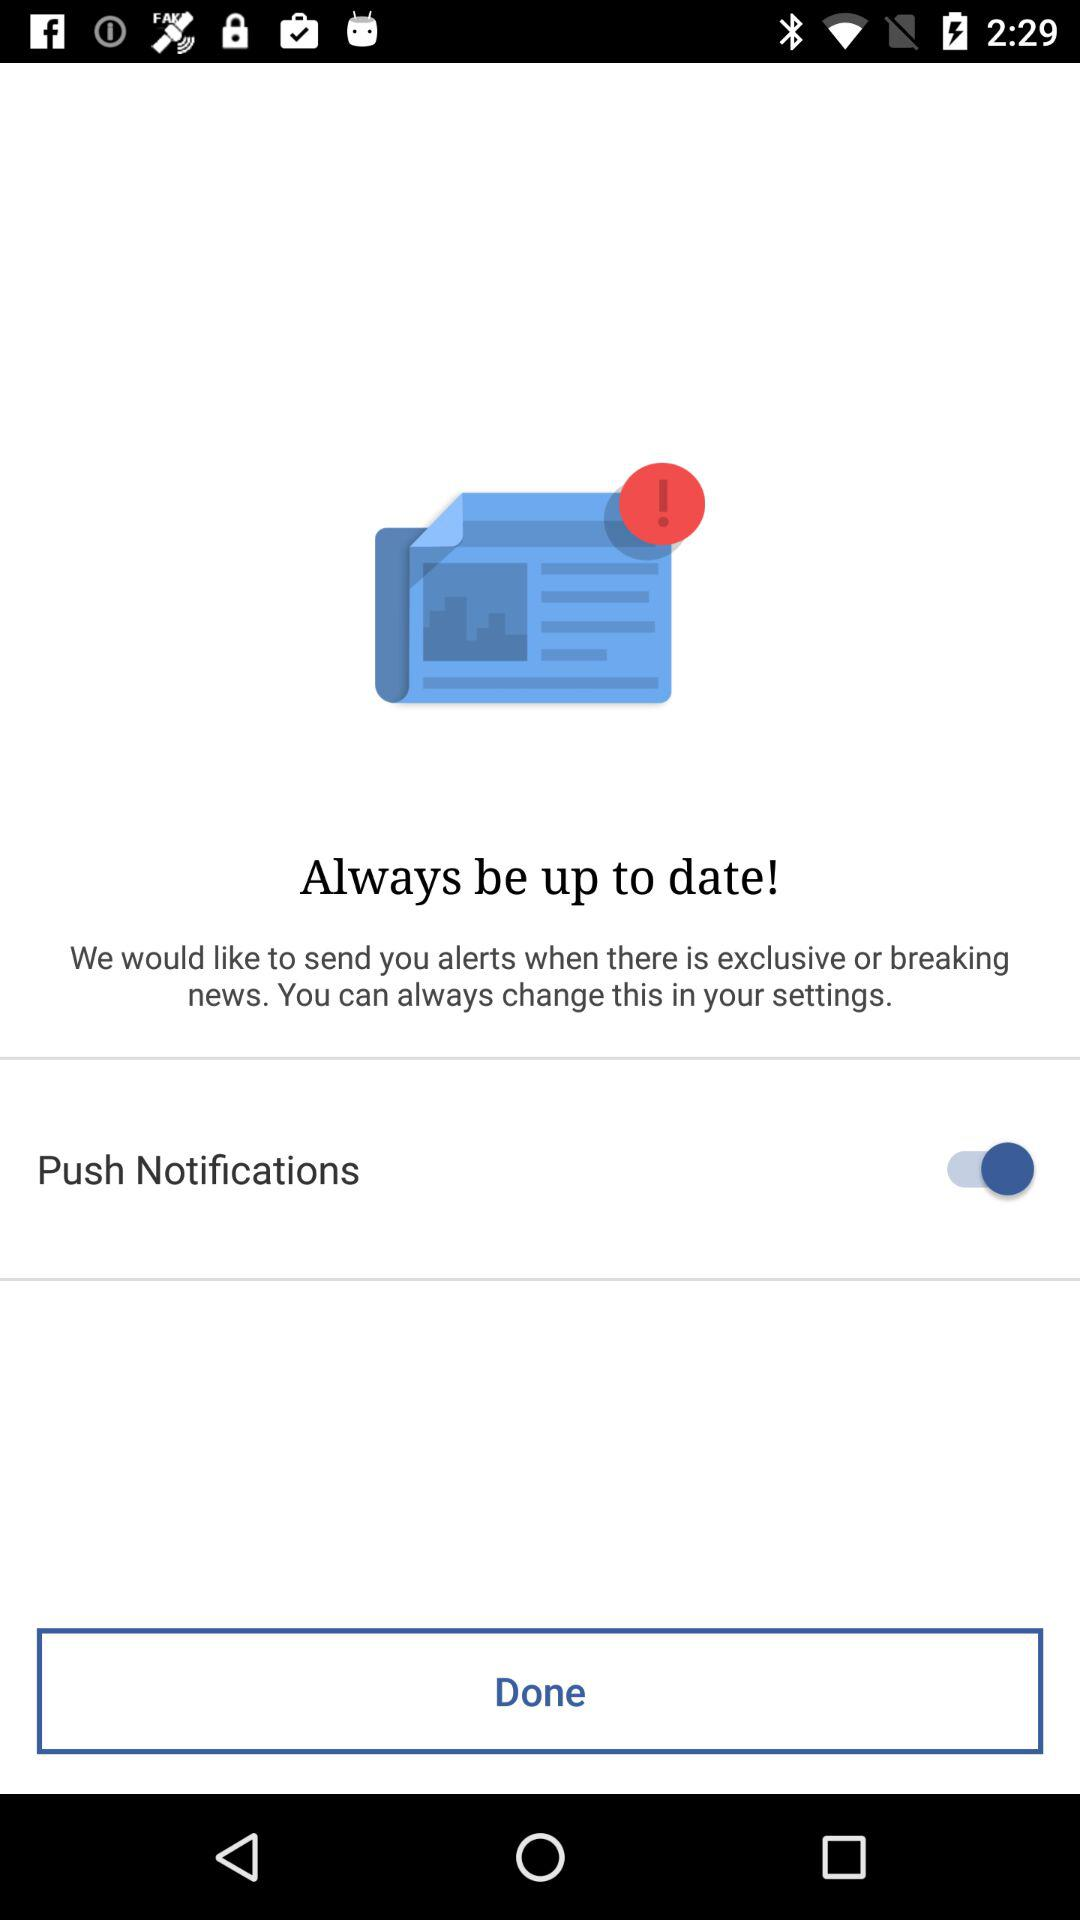What is the status of the "Push Notifications"? The status of the "Push Notifications" is "on". 